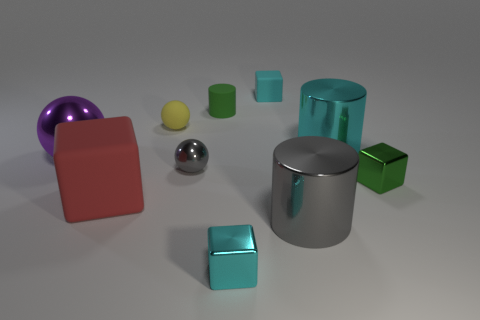How many large cubes are on the right side of the green thing that is to the right of the cyan metal cylinder that is behind the gray shiny cylinder?
Offer a terse response. 0. The small cyan object behind the red rubber object that is in front of the tiny shiny block that is behind the red thing is made of what material?
Ensure brevity in your answer.  Rubber. Do the tiny green thing that is behind the small green shiny object and the big red cube have the same material?
Keep it short and to the point. Yes. How many purple spheres have the same size as the yellow thing?
Provide a succinct answer. 0. Is the number of matte cubes on the left side of the tiny cyan rubber object greater than the number of green rubber things in front of the large gray metal cylinder?
Ensure brevity in your answer.  Yes. Are there any cyan objects of the same shape as the green rubber object?
Provide a short and direct response. Yes. How big is the cyan metallic thing right of the cyan block behind the tiny green metallic block?
Provide a short and direct response. Large. The big gray thing that is in front of the large metal cylinder on the right side of the big gray metallic thing that is in front of the small rubber block is what shape?
Offer a very short reply. Cylinder. What is the size of the green cube that is made of the same material as the cyan cylinder?
Provide a succinct answer. Small. Are there more large brown metal spheres than small cyan rubber objects?
Offer a very short reply. No. 